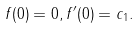<formula> <loc_0><loc_0><loc_500><loc_500>f ( 0 ) = 0 , f ^ { \prime } ( 0 ) = c _ { 1 } .</formula> 